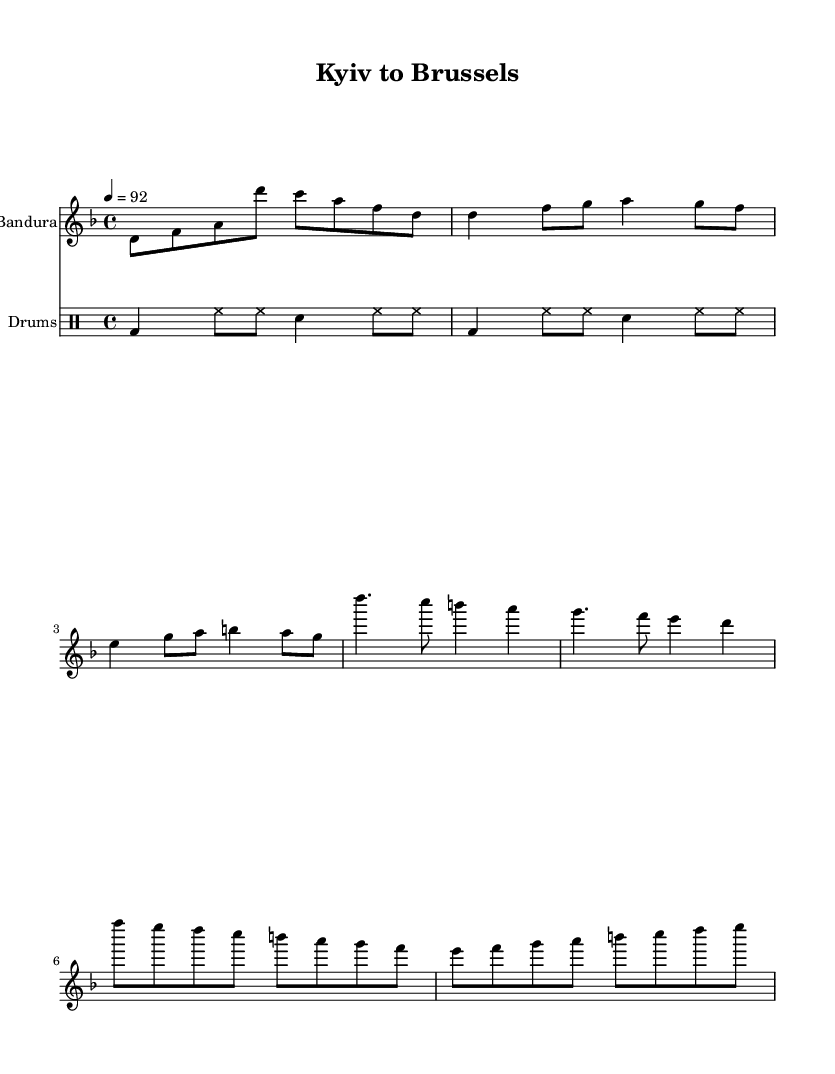What is the key signature of this music? The key signature is D minor, which includes one flat (B flat). This can be identified in the upper part of the sheet music where the key signature is written.
Answer: D minor What is the time signature of this music? The time signature is 4/4, indicated at the beginning of the score. This means that there are four beats in each measure and the quarter note gets one beat.
Answer: 4/4 What is the tempo marking for this piece? The tempo marking is 92 beats per minute, shown at the beginning of the score as "4 = 92". This indicates the speed or pace of the music.
Answer: 92 How many measures are there in the chorus section? The chorus section consists of 2 measures, which can be counted in the notation shown. Each measure is separated by a vertical line.
Answer: 2 What instrument is the primary melodic instrument in this piece? The primary melodic instrument is the Bandura, which is specified in the staff as its instrument name. This instrument typically plays the melody while the drums provide rhythm.
Answer: Bandura What kind of rhythmic figure is used in the drum kit pattern? The drum kit uses a basic rhythmic pattern consisting of bass drum (bd) and hi-hats (hh) with snare drum (sn) accents. This can be observed in the drum notation which shows a repetitive structure.
Answer: Basic pattern What folk element is incorporated in this hip-hop fusion? The incorporation of the Bandura introduces a traditional Ukrainian folk element into the hip-hop fusion genre, providing cultural significance and a unique sound texture. This can be inferred from the instrumentation used alongside hip-hop rhythms.
Answer: Bandura 